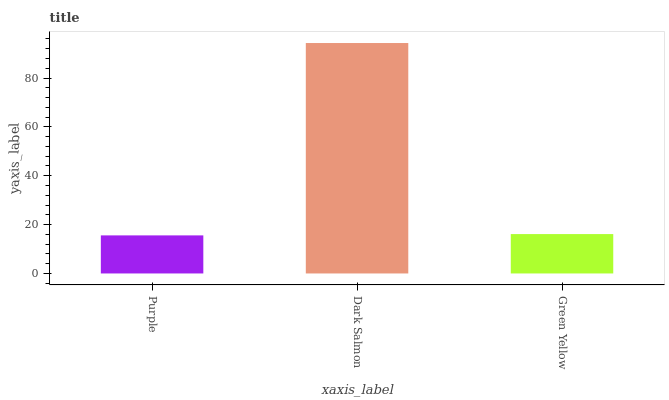Is Purple the minimum?
Answer yes or no. Yes. Is Dark Salmon the maximum?
Answer yes or no. Yes. Is Green Yellow the minimum?
Answer yes or no. No. Is Green Yellow the maximum?
Answer yes or no. No. Is Dark Salmon greater than Green Yellow?
Answer yes or no. Yes. Is Green Yellow less than Dark Salmon?
Answer yes or no. Yes. Is Green Yellow greater than Dark Salmon?
Answer yes or no. No. Is Dark Salmon less than Green Yellow?
Answer yes or no. No. Is Green Yellow the high median?
Answer yes or no. Yes. Is Green Yellow the low median?
Answer yes or no. Yes. Is Dark Salmon the high median?
Answer yes or no. No. Is Purple the low median?
Answer yes or no. No. 